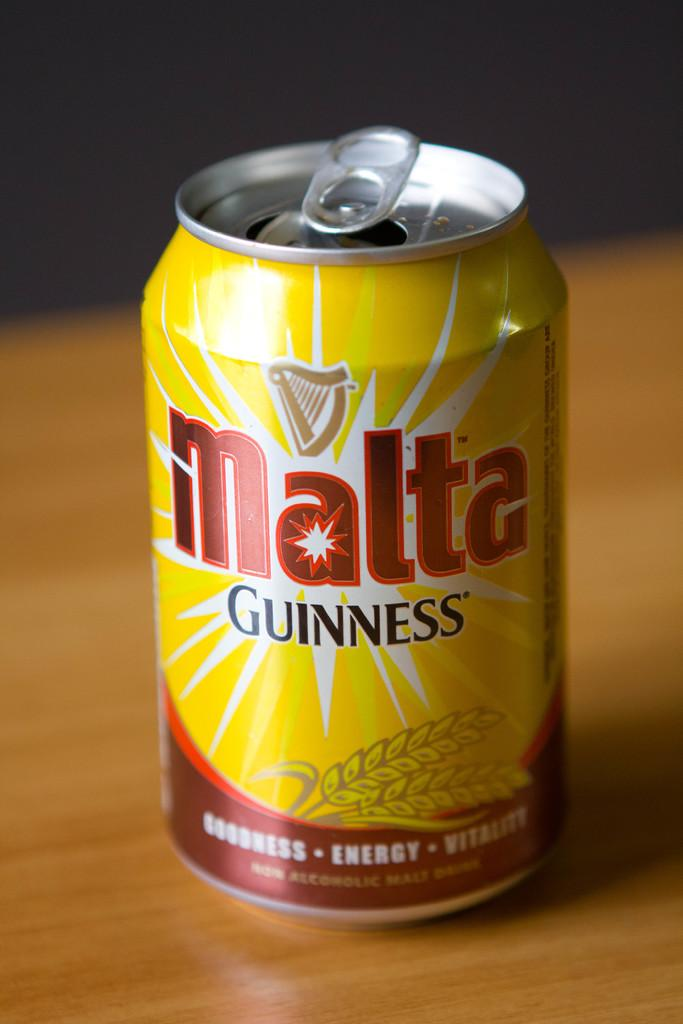<image>
Render a clear and concise summary of the photo. A can of Malta non alcoholic malt beverage. 